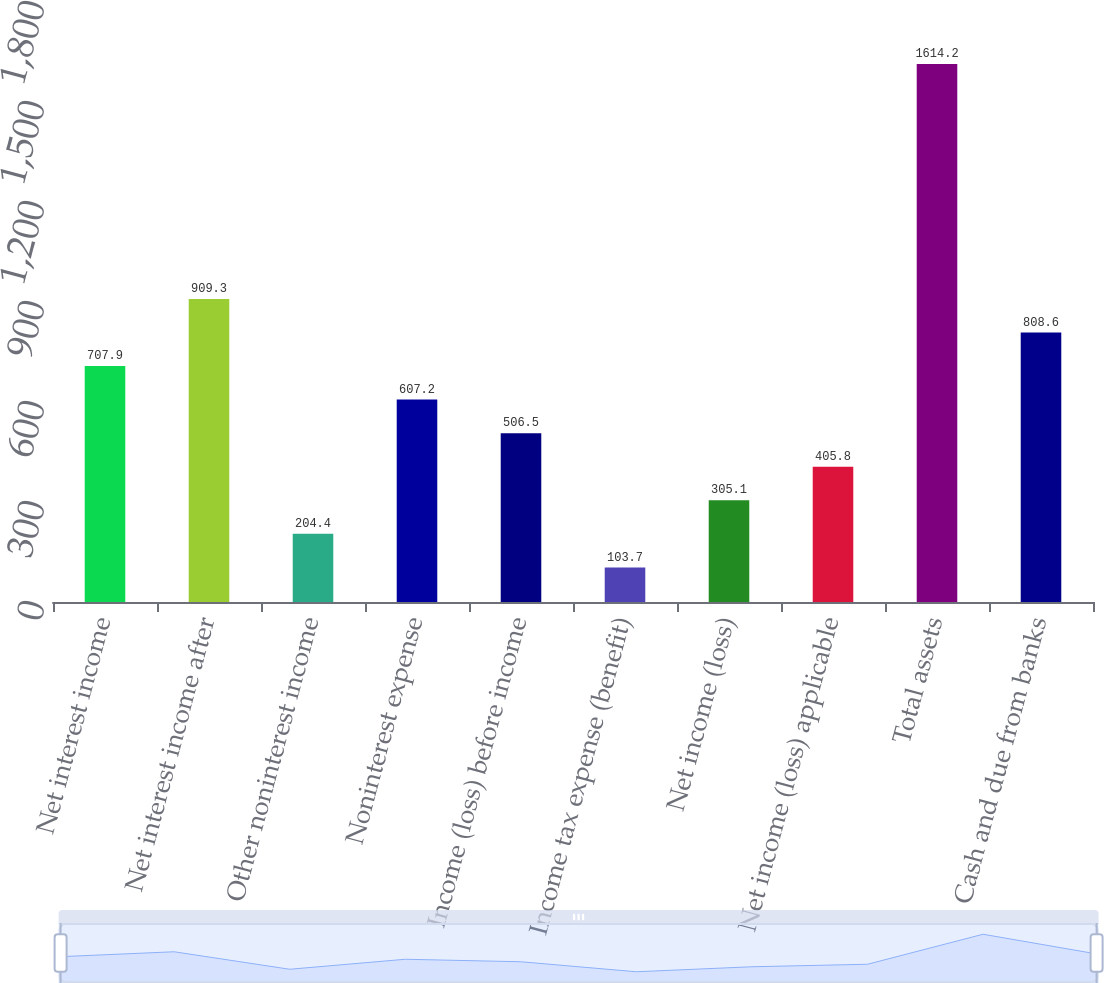Convert chart. <chart><loc_0><loc_0><loc_500><loc_500><bar_chart><fcel>Net interest income<fcel>Net interest income after<fcel>Other noninterest income<fcel>Noninterest expense<fcel>Income (loss) before income<fcel>Income tax expense (benefit)<fcel>Net income (loss)<fcel>Net income (loss) applicable<fcel>Total assets<fcel>Cash and due from banks<nl><fcel>707.9<fcel>909.3<fcel>204.4<fcel>607.2<fcel>506.5<fcel>103.7<fcel>305.1<fcel>405.8<fcel>1614.2<fcel>808.6<nl></chart> 